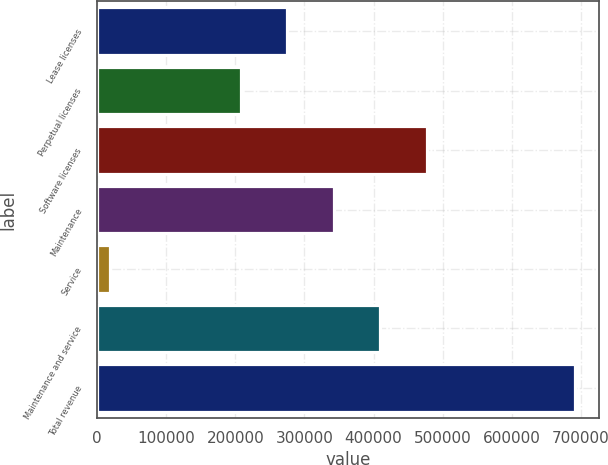Convert chart to OTSL. <chart><loc_0><loc_0><loc_500><loc_500><bar_chart><fcel>Lease licenses<fcel>Perpetual licenses<fcel>Software licenses<fcel>Maintenance<fcel>Service<fcel>Maintenance and service<fcel>Total revenue<nl><fcel>275119<fcel>207876<fcel>476847<fcel>342361<fcel>19022<fcel>409604<fcel>691449<nl></chart> 